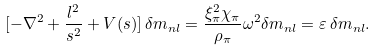Convert formula to latex. <formula><loc_0><loc_0><loc_500><loc_500>[ - \nabla ^ { 2 } + \frac { l ^ { 2 } } { s ^ { 2 } } + V ( s ) ] \, \delta m _ { n l } = \frac { \xi ^ { 2 } _ { \pi } \chi _ { \pi } } { \rho _ { \pi } } \omega ^ { 2 } \delta m _ { n l } = \varepsilon \, \delta m _ { n l } .</formula> 